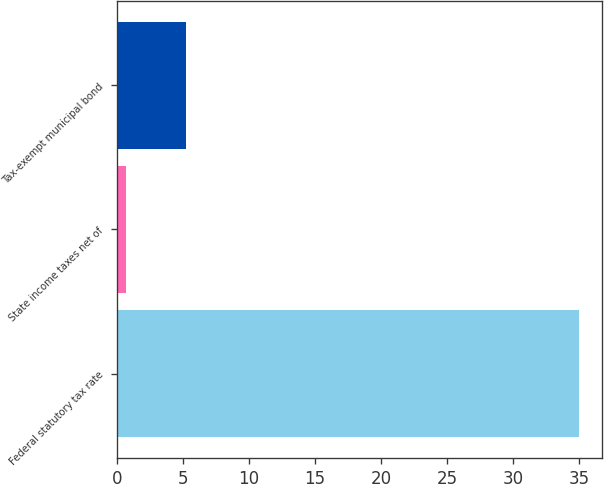Convert chart to OTSL. <chart><loc_0><loc_0><loc_500><loc_500><bar_chart><fcel>Federal statutory tax rate<fcel>State income taxes net of<fcel>Tax-exempt municipal bond<nl><fcel>35<fcel>0.7<fcel>5.2<nl></chart> 